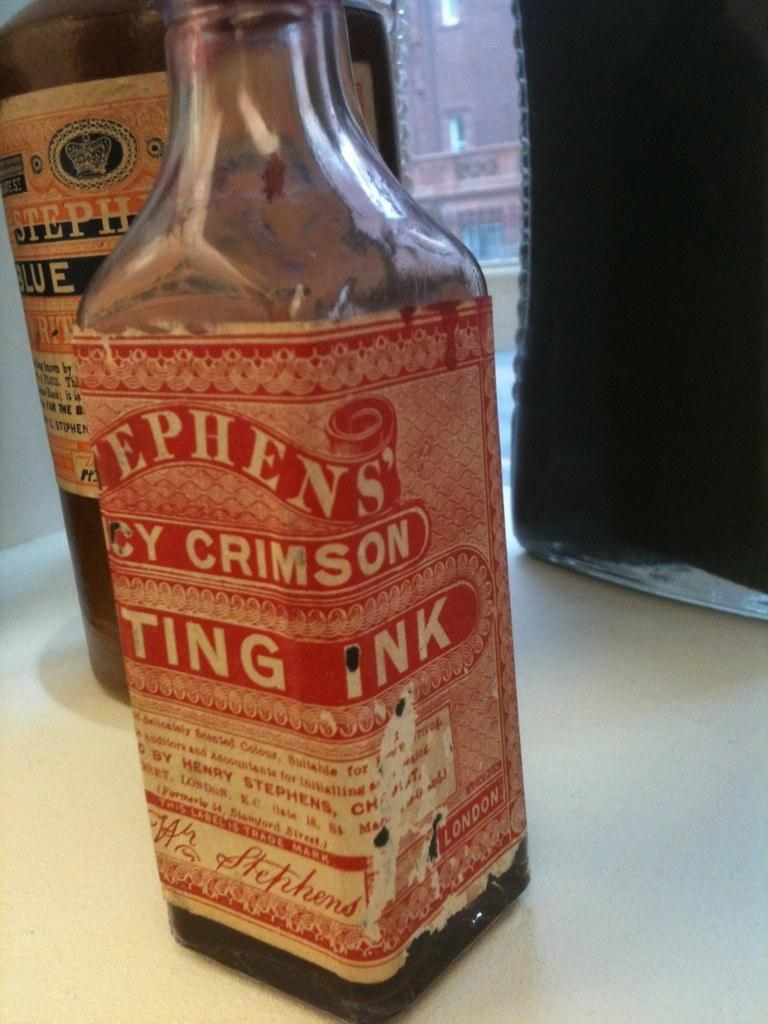<image>
Relay a brief, clear account of the picture shown. Bottle of Stephen's next to another bottle by Stephens'. 